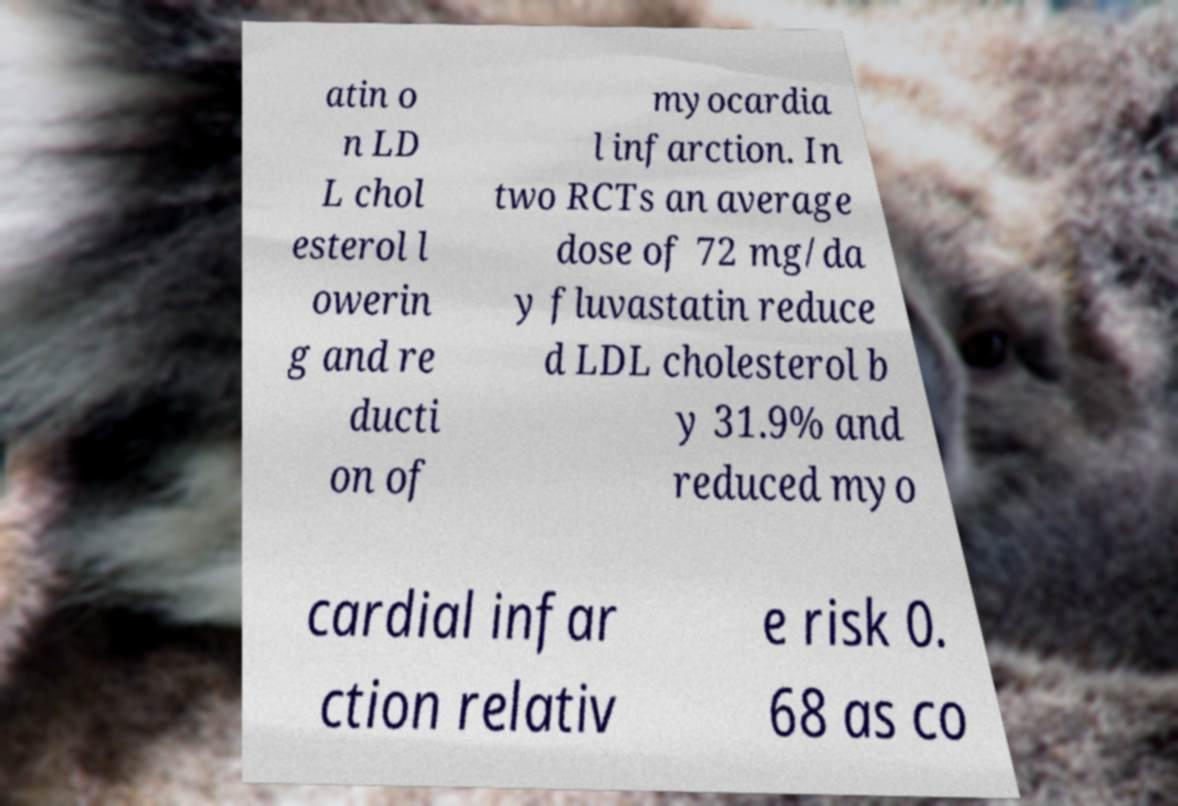Can you read and provide the text displayed in the image?This photo seems to have some interesting text. Can you extract and type it out for me? atin o n LD L chol esterol l owerin g and re ducti on of myocardia l infarction. In two RCTs an average dose of 72 mg/da y fluvastatin reduce d LDL cholesterol b y 31.9% and reduced myo cardial infar ction relativ e risk 0. 68 as co 